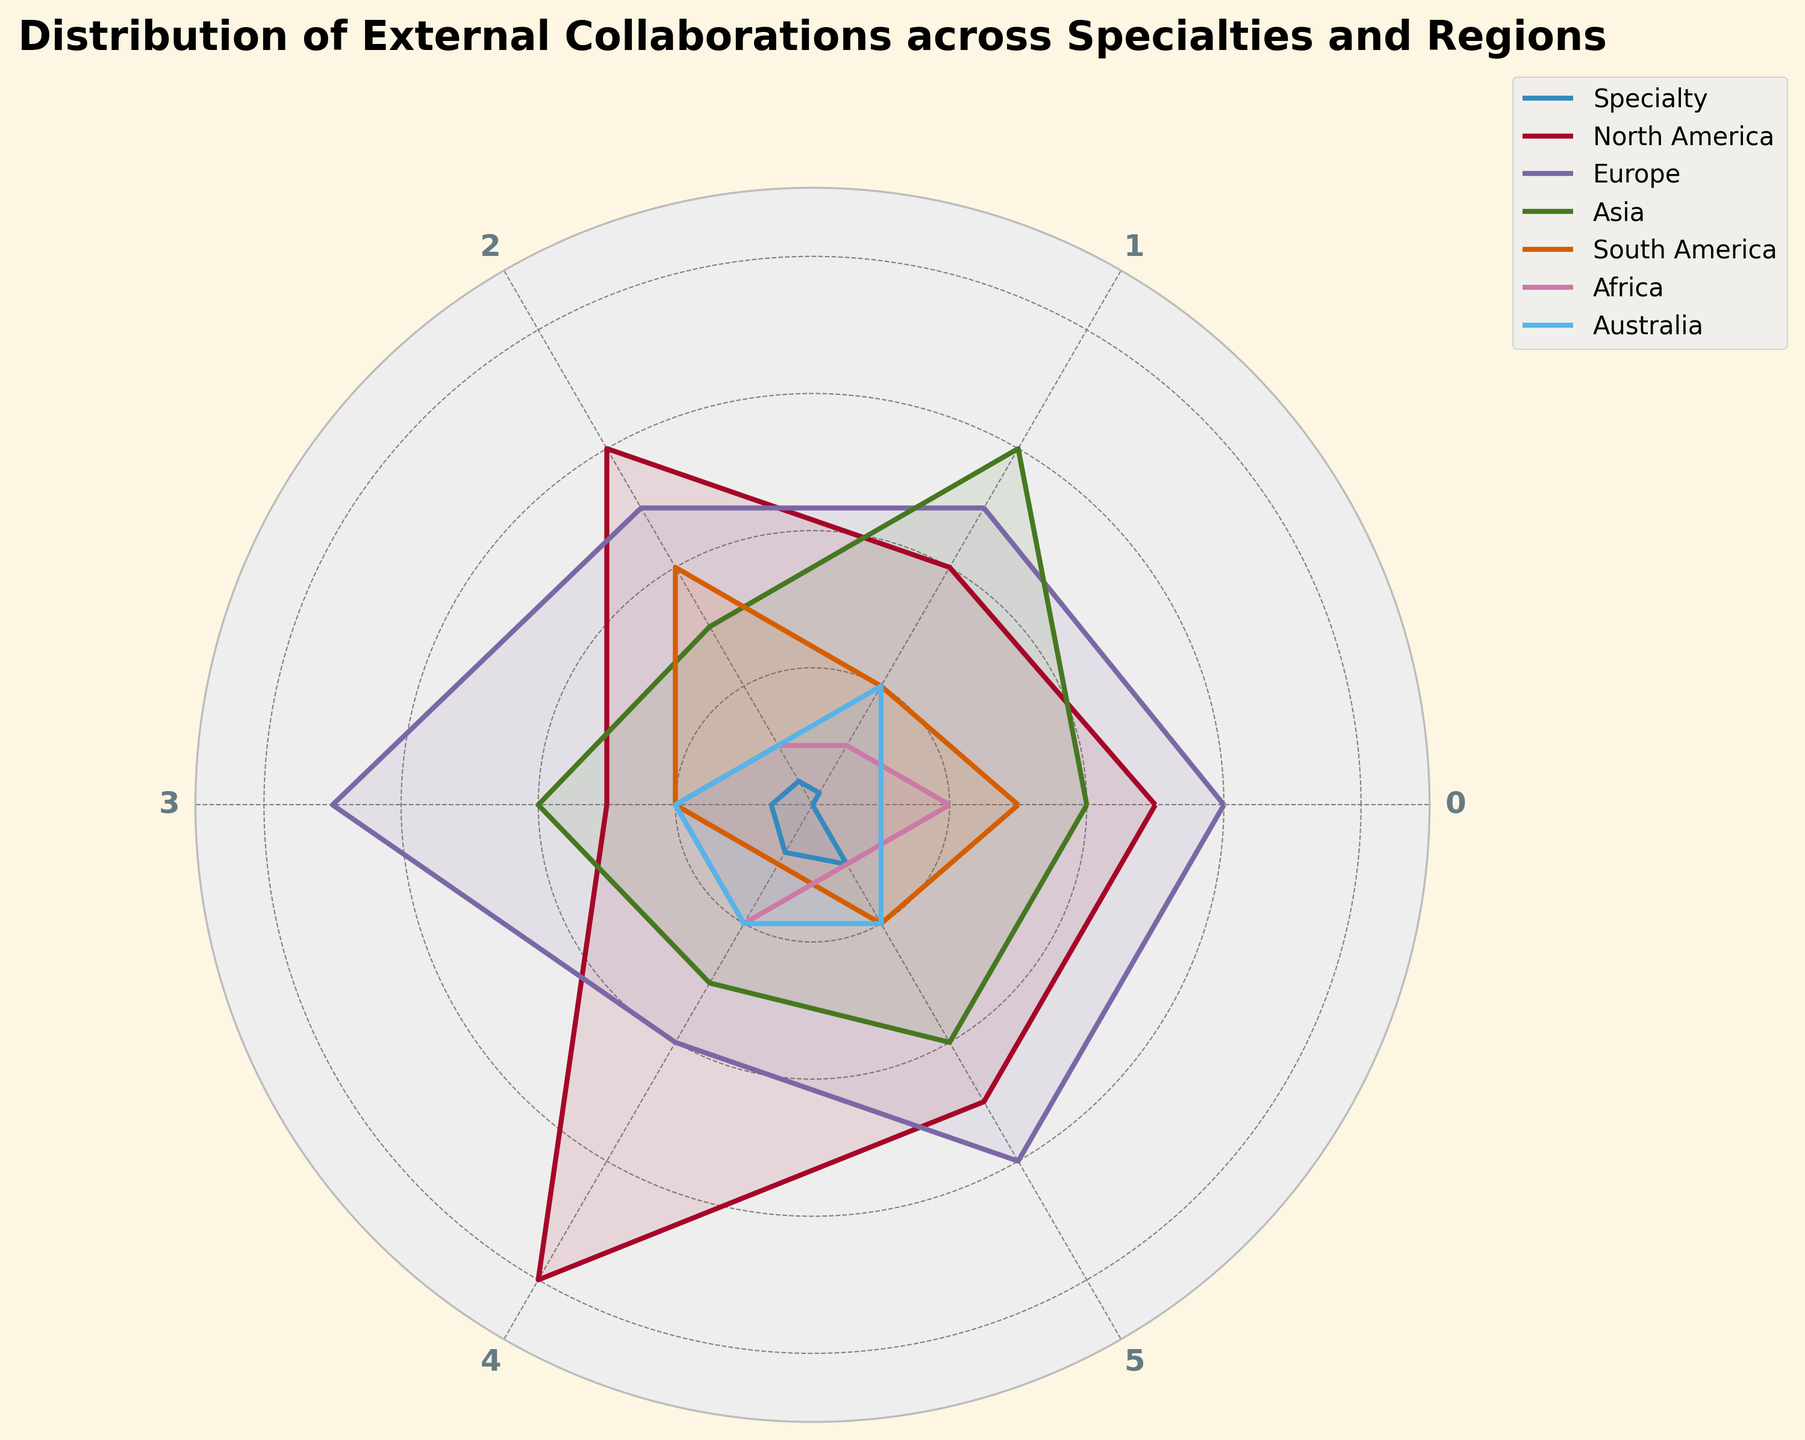What title is given to the figure? The title of a figure is typically positioned at the top and often provides a summary of what the figure is about. In this case, the title "Distribution of External Collaborations across Specialties and Regions" succinctly describes the content illustrated by the radar chart.
Answer: Distribution of External Collaborations across Specialties and Regions Which specialty has the highest number of collaborations in North America? By examining the radar chart, we can see that each spoke represents different specialties and each line/color for a region represents the number of collaborations. The specialty closest to the highest value for North America is Climatology.
Answer: Climatology What is the average number of collaborations for Marine Biology across all regions? To calculate the average, sum up the collaborations for Marine Biology across all regions (25 for North America, 30 for Europe, 20 for Asia, 15 for South America, 10 for Africa, 5 for Australia) and divide by the number of regions (6). Thus, (25+30+20+15+10+5)/6 = 105/6 = 17.5
Answer: 17.5 Which two specialties have the closest number of collaborations in Europe? By comparing the values for Europe directly from the radar chart spokes, we notice that Conservation Biology and Biodiversity both have close values in Europe, at 25 and 30 respectively.
Answer: Conservation Biology and Biodiversity Which region shows the most balanced collaboration numbers across all specialties? A balanced collaboration means that the values don’t vary too widely across the specialties in that region. Comparing the lines on the radar chart, Australia has values of 5, 10, 5, 10, 10, 10, which are relatively close to each other, indicating a balanced distribution.
Answer: Australia By how much do Forestry collaborations in Asia exceed those in South America? Look at the Forestry specialization and compare the value for Asia (30) with the value for South America (10). The difference is found by subtracting the latter from the former. Thus, 30 - 10 = 20.
Answer: 20 Rank the regions by the number of collaborations in Conservation Biology from highest to lowest. Locate Conservation Biology on the radar chart and order its values by region: North America (30), South America (20), Europe (25), Asia (15), Australia (5), Africa (5). The sequence from highest to lowest is North America, Europe, South America, Asia, Australia, and Africa.
Answer: North America, Europe, South America, Asia, Australia, and Africa Which specialty has the lowest collaborations in Africa and what is the value? Find the lowest point on the radar chart corresponding to Africa and identify the specialty it associates with. Both Conservation Biology and Marine Biology show the lowest value of 5 in Africa.
Answer: Marine Biology and Conservation Biology, value is 5 